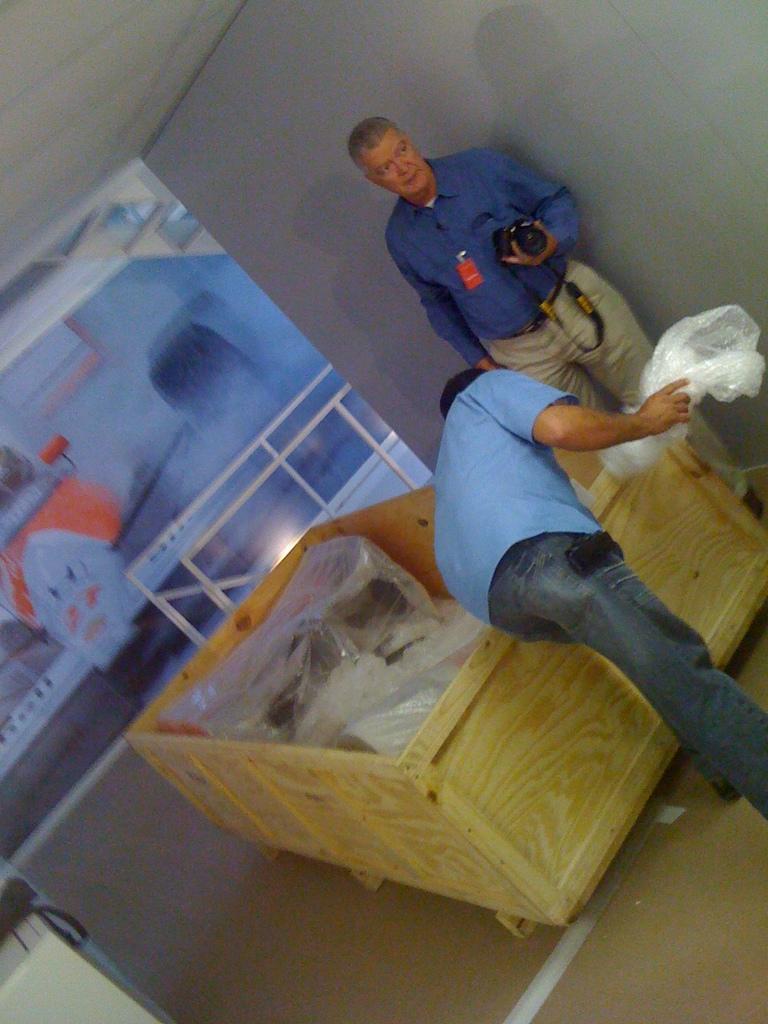In one or two sentences, can you explain what this image depicts? In this picture, we see the man in the blue shirt is standing. He is holding the camera in his hand. Beside him, we see the wooden box in which some objects and plastic covers are placed. Beside that, we see a man in the blue T-shirt is holding the plastic cover. In the left bottom, we see a white table on which a black color object is placed. In the background, we see the railing and a white wall. We even see the painting on the wall. In the left top, we see the roof of the room. 